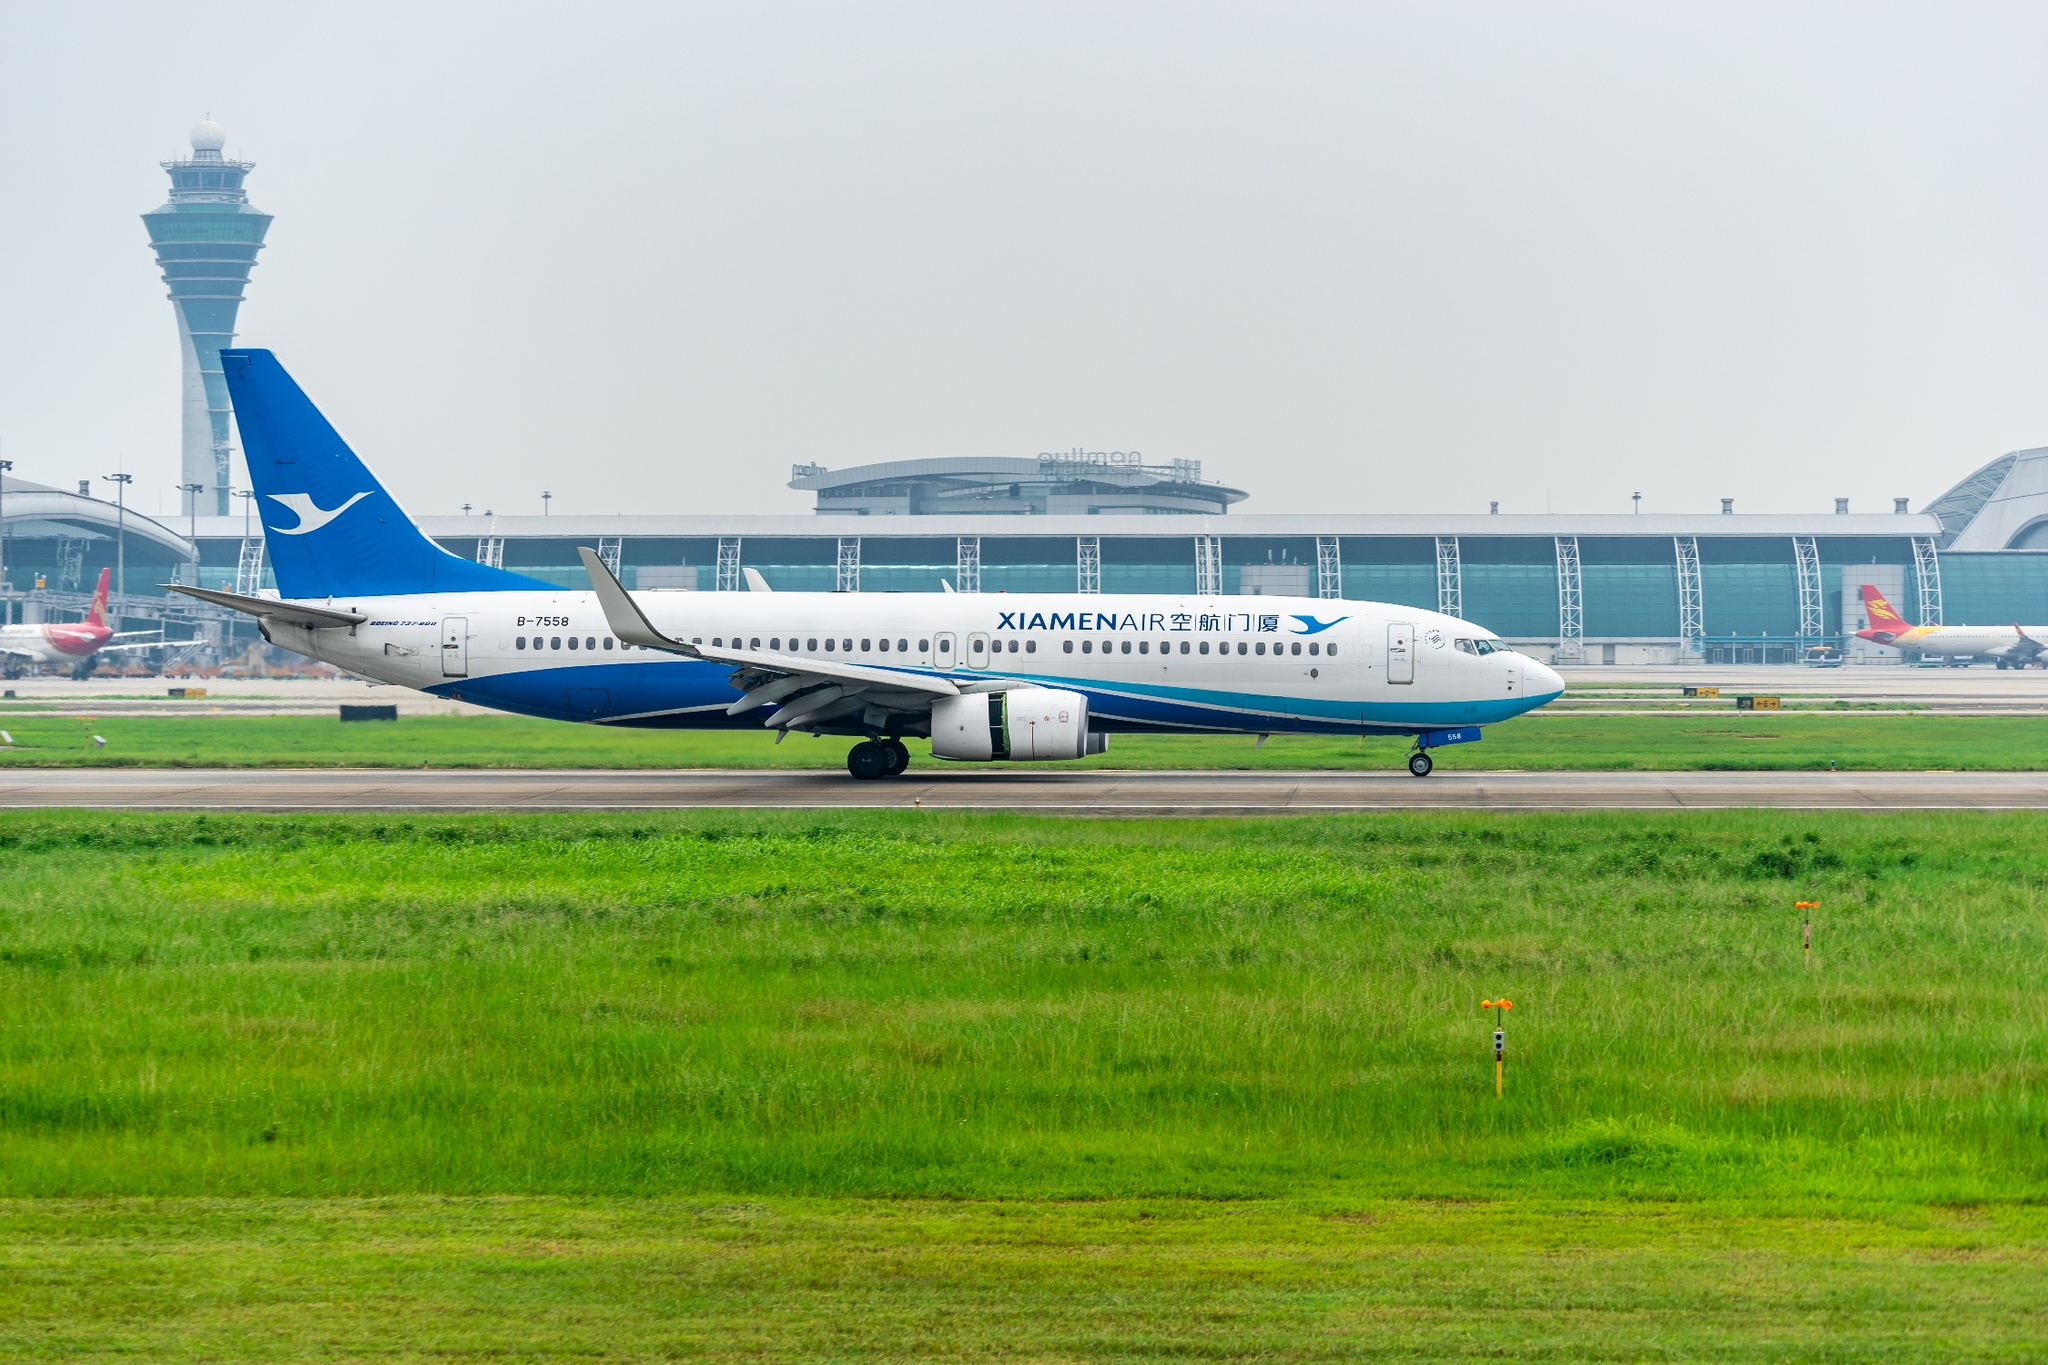Craft a fictional adventure story involving this airplane. Once upon a time, the XiamenAir Boeing 737-800 named 'Sky Voyager' embarked on a secret mission. One day, a mysterious passenger boarded with an ancient map leading to a hidden island in the South Pacific. As 'Sky Voyager' soared through the skies, it encountered fierce storms and challenges, but its experienced pilots navigated the treacherous weather with skill. Upon reaching the island, the crew discovered remnants of an ancient civilization and rare treasures. With the help of the local villagers, they unearthed a treasure trove of artifacts that shed light on a forgotten history. 'Sky Voyager' then returned to Xiamen, its hold filled with the precious relics, bringing newfound knowledge and stories to share with the world. This adventure was one for the history books, and 'Sky Voyager' became a celebrated aircraft with tales of bravery, discovery, and exploration. 